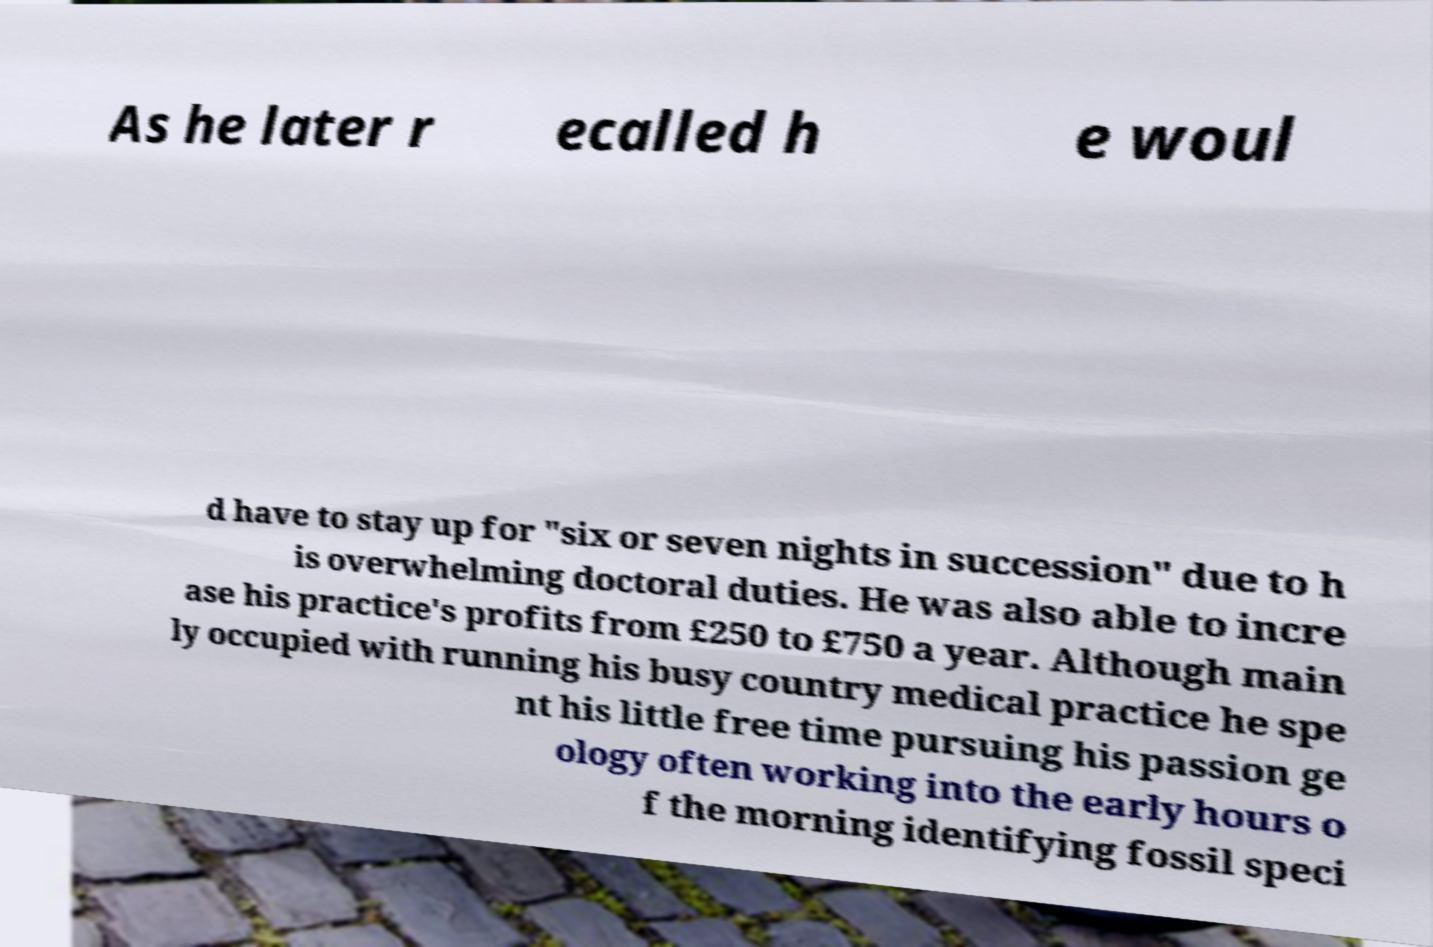I need the written content from this picture converted into text. Can you do that? As he later r ecalled h e woul d have to stay up for "six or seven nights in succession" due to h is overwhelming doctoral duties. He was also able to incre ase his practice's profits from £250 to £750 a year. Although main ly occupied with running his busy country medical practice he spe nt his little free time pursuing his passion ge ology often working into the early hours o f the morning identifying fossil speci 